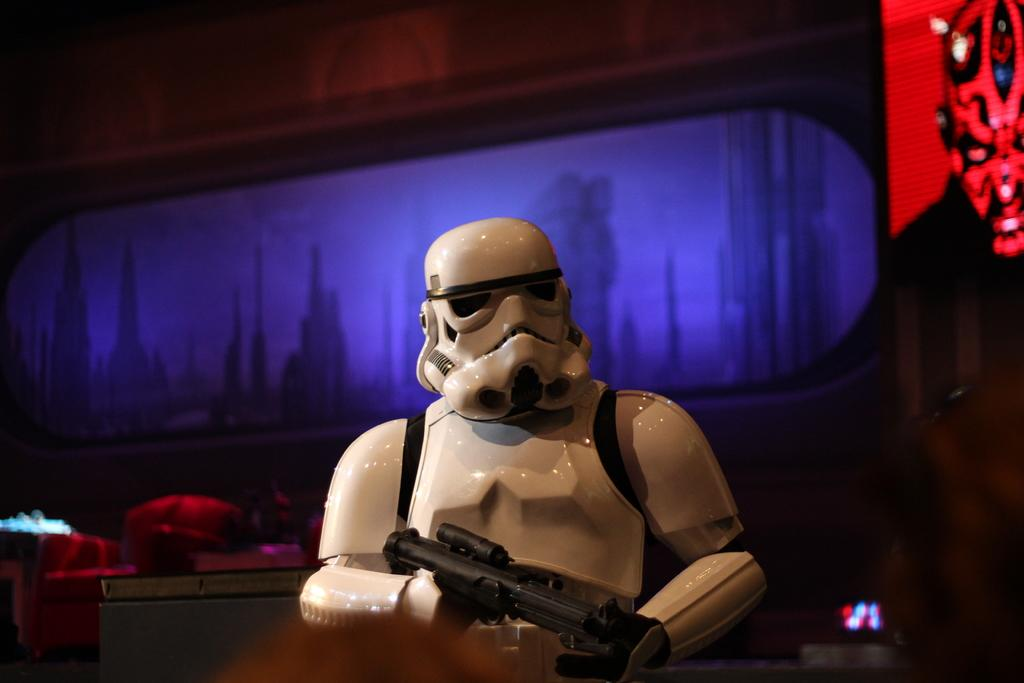What is the main subject of the image? There is a robot in the image. What is the robot holding in its hand? The robot is holding a gun. What can be seen behind the robot? There is a screen behind the robot. How many slaves can be seen working in the river in the image? There are no slaves or rivers present in the image; it features a robot holding a gun with a screen in the background. 